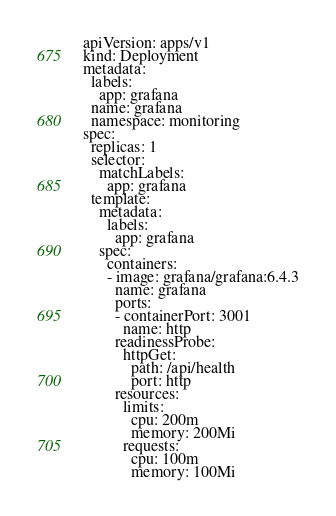Convert code to text. <code><loc_0><loc_0><loc_500><loc_500><_YAML_>apiVersion: apps/v1
kind: Deployment
metadata:
  labels:
    app: grafana
  name: grafana
  namespace: monitoring
spec:
  replicas: 1
  selector:
    matchLabels:
      app: grafana
  template:
    metadata:
      labels:
        app: grafana
    spec:
      containers:
      - image: grafana/grafana:6.4.3
        name: grafana
        ports:
        - containerPort: 3001
          name: http
        readinessProbe:
          httpGet:
            path: /api/health
            port: http
        resources:
          limits:
            cpu: 200m
            memory: 200Mi
          requests:
            cpu: 100m
            memory: 100Mi
</code> 